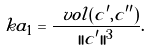<formula> <loc_0><loc_0><loc_500><loc_500>\ k a _ { 1 } = \frac { \ v o l ( c ^ { \prime } , c ^ { \prime \prime } ) } { | | c ^ { \prime } | | ^ { 3 } } .</formula> 